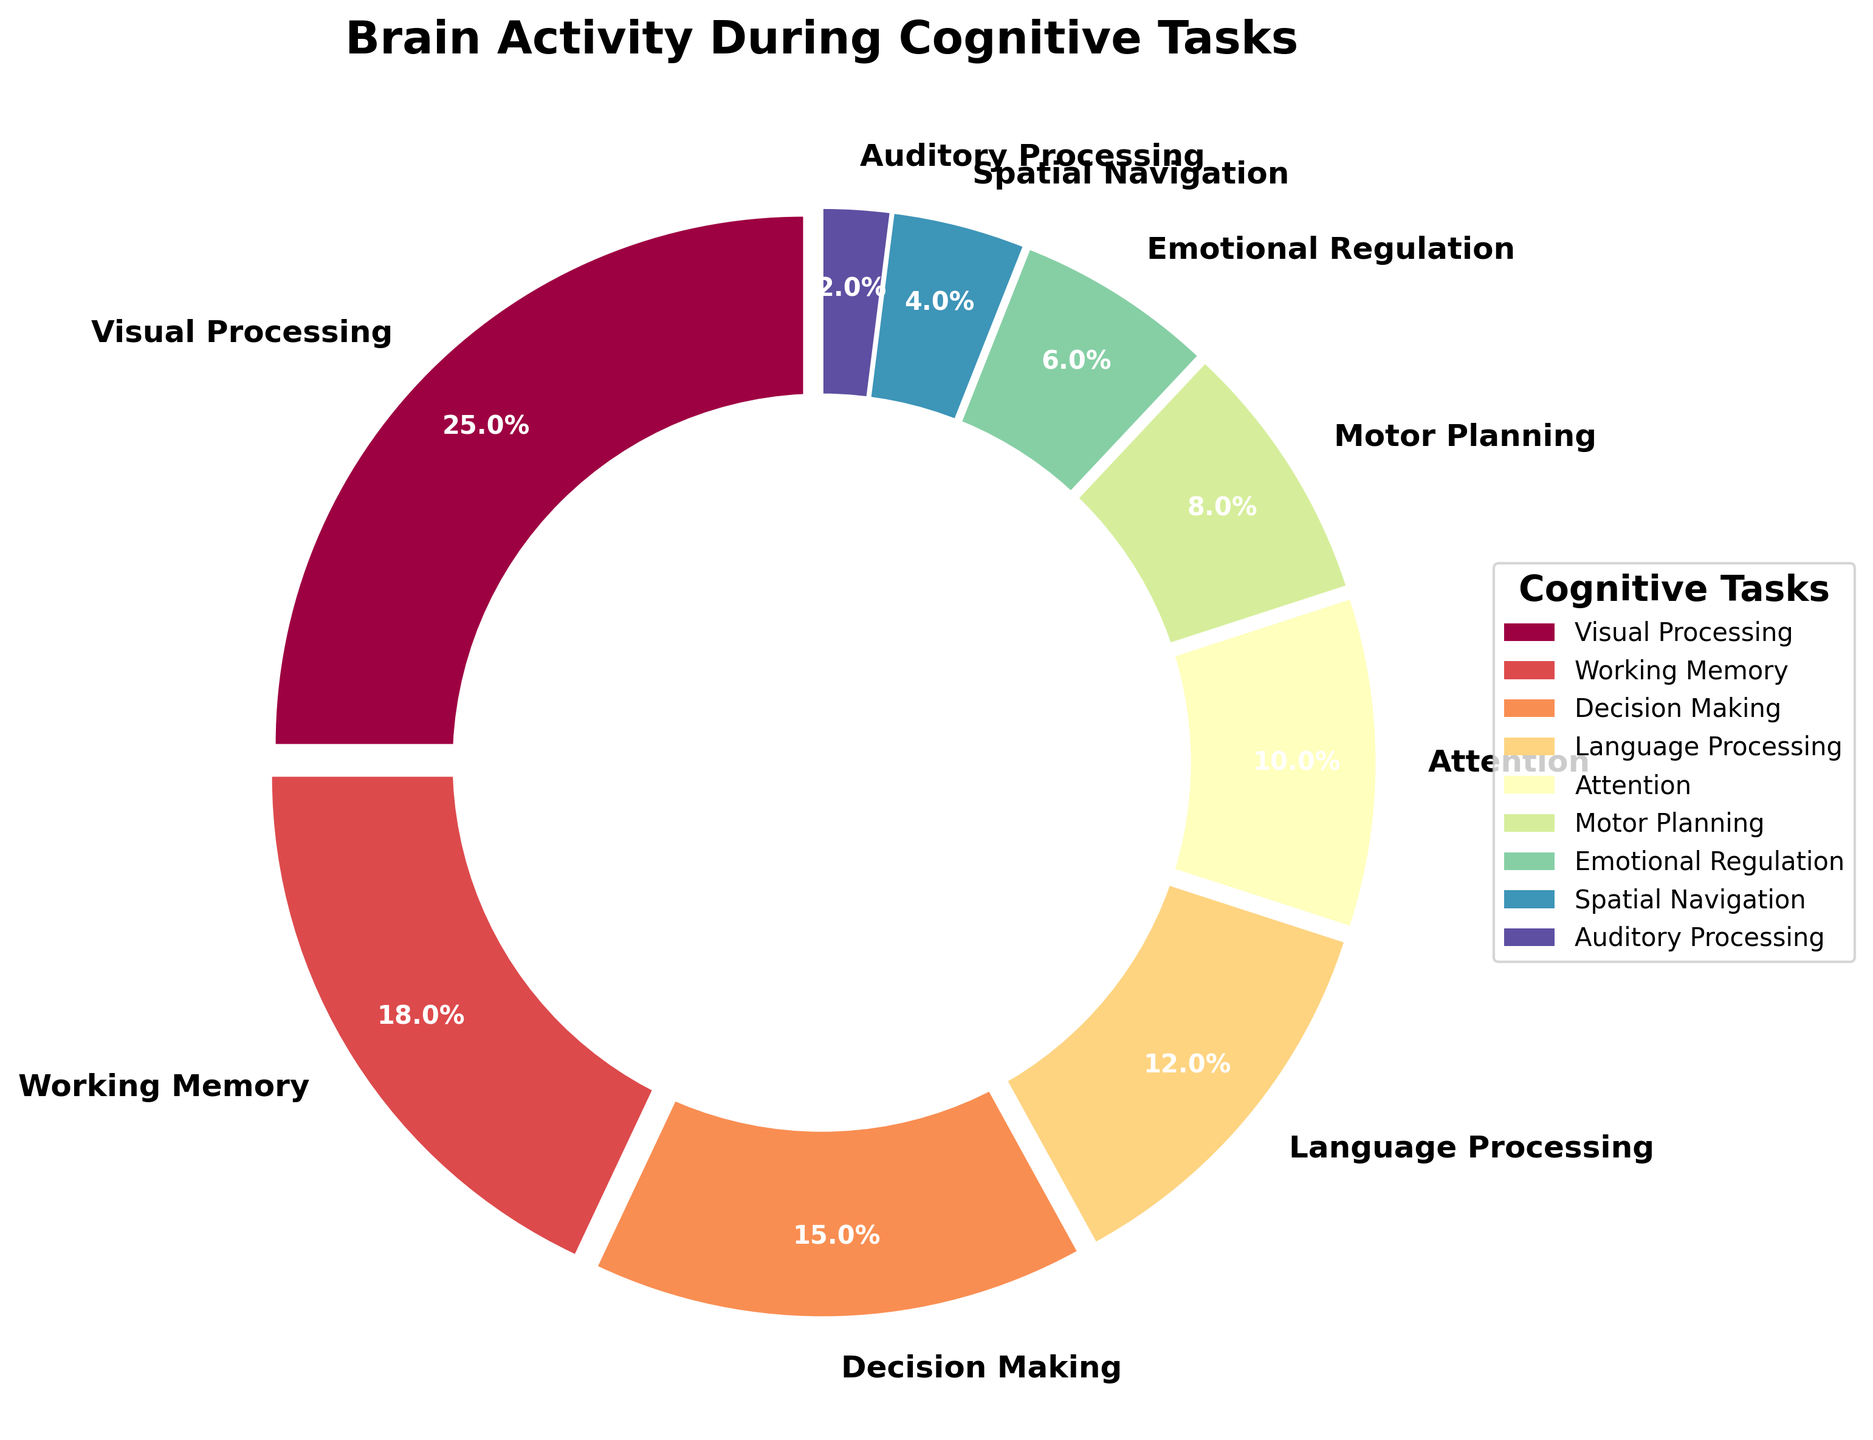What is the percentage of brain activity dedicated to Visual Processing? Observing the pie chart, we can see the segment labeled "Visual Processing" which states 25%.
Answer: 25% Which cognitive task has the smallest percentage of brain activity? Looking at the pie chart, the smallest segment is labeled "Auditory Processing" with 2%.
Answer: Auditory Processing What is the combined percentage of brain activity for Language Processing and Decision Making? From the figure, Language Processing is 12% and Decision Making is 15%. Adding these together, 12% + 15% = 27%.
Answer: 27% How does the percentage of Emotional Regulation compare to Attention? Emotional Regulation is 6% and Attention is 10%. Emotional Regulation has a lower percentage than Attention.
Answer: Lower Which task occupies more brain activity, Motor Planning or Spatial Navigation? Looking at their respective sections, Motor Planning is 8% while Spatial Navigation is 4%. Motor Planning occupies more brain activity than Spatial Navigation.
Answer: Motor Planning What is the visual attribute of the segment representing Working Memory? The segment representing Working Memory is distinguishable by its color and position as well as labeled with 18%.
Answer: 18%, Spectral color scheme What is the difference in brain activity percentage between Motor Planning and Auditory Processing? Motor Planning is 8% and Auditory Processing is 2%. The difference is 8% - 2% = 6%.
Answer: 6% What two cognitive tasks combined equal a percentage close to 20%, and what are those percentages? Attention is 10% and Motor Planning is 8%. Combined, they give 10% + 8% = 18%, which is close to 20%.
Answer: Attention (10%) and Motor Planning (8%) What's the total percentage dedicated to non-sensory processing tasks (excluding Visual, Auditory, and Language Processing)? Total percentage = 100%; sum of Visual, Auditory, and Language Processing = 25% + 2% + 12% = 39%; non-sensory = 100% - 39% = 61%.
Answer: 61% If you were to divide the pie chart into two halves, comprising the top four and bottom five sections respectively, which half has a greater total percentage? Top four percentages: Visual (25%), Working Memory (18%), Decision Making (15%), Language (12%) = 70%; Bottom five percentages: Attention (10%), Motor Planning (8%), Emotional Regulation (6%), Spatial Navigation (4%), Auditory (2%) = 30%; Top half is greater.
Answer: Top half 